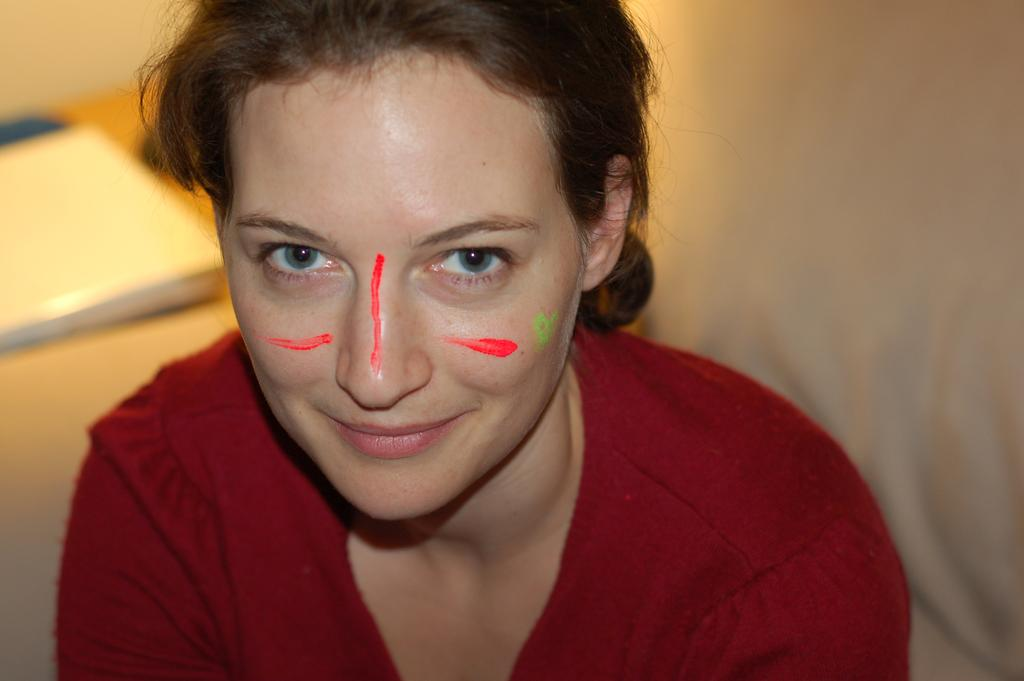Who is the main subject in the image? There is a woman in the image. What can be observed on the woman's face? There is color on the woman's face. Can you describe the background of the image? The background of the image is blurred. How does the woman plan to increase the linen production in the image? There is no mention of linen production or any related activities in the image. 